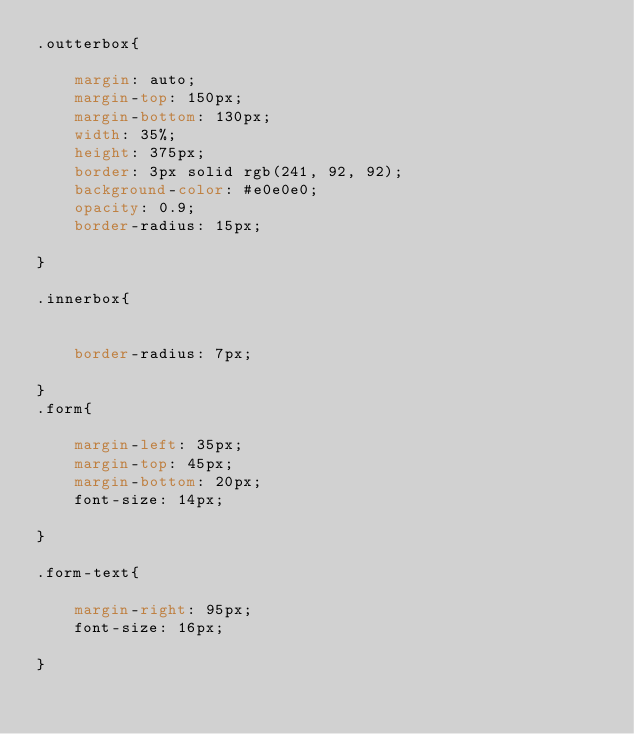Convert code to text. <code><loc_0><loc_0><loc_500><loc_500><_CSS_>.outterbox{

    margin: auto;
    margin-top: 150px;
    margin-bottom: 130px;
    width: 35%;
    height: 375px;
    border: 3px solid rgb(241, 92, 92);
    background-color: #e0e0e0;
    opacity: 0.9;
    border-radius: 15px;

}

.innerbox{


    border-radius: 7px;
   
}
.form{

    margin-left: 35px;
    margin-top: 45px;
    margin-bottom: 20px;
    font-size: 14px;

}

.form-text{

    margin-right: 95px;
    font-size: 16px;

}
</code> 